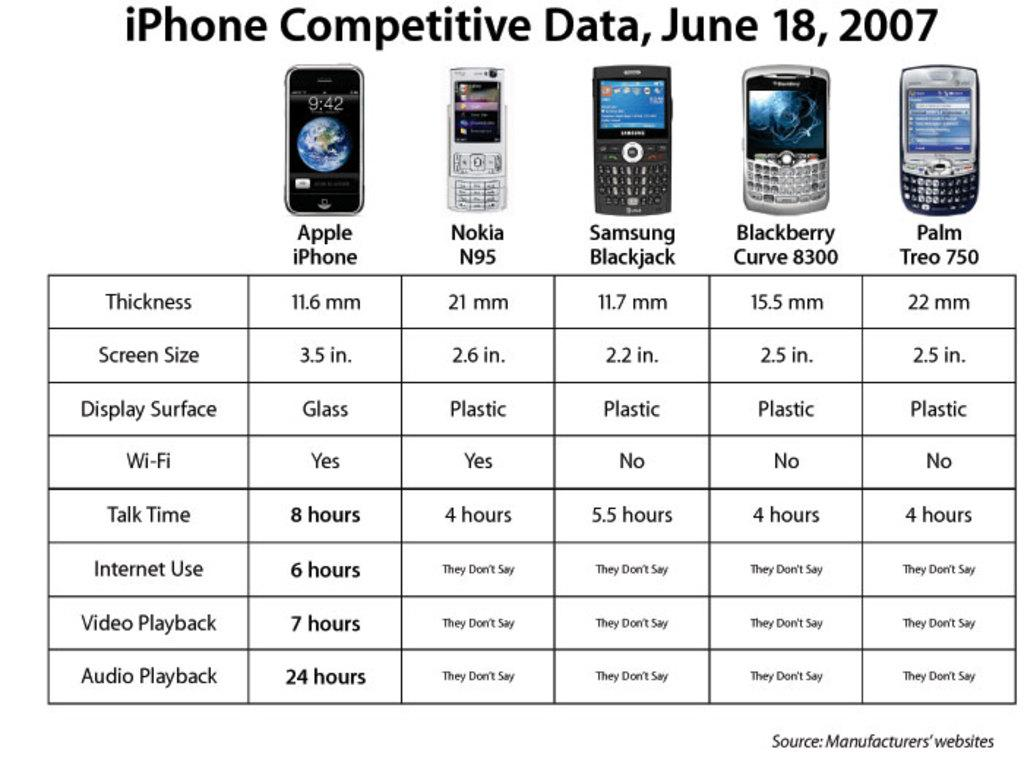<image>
Present a compact description of the photo's key features. An iphone competitive data chart with Nokia, Samsung Blackjack, Blackberry Curve 8300, and Palm Treo 750 